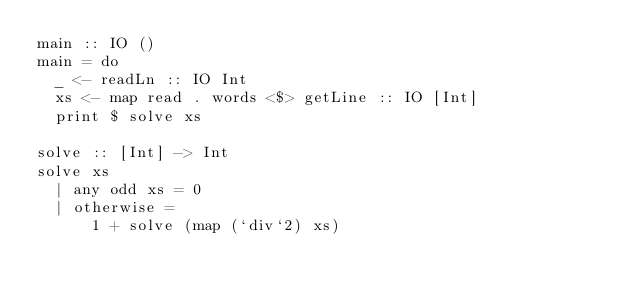Convert code to text. <code><loc_0><loc_0><loc_500><loc_500><_Haskell_>main :: IO ()
main = do
  _ <- readLn :: IO Int
  xs <- map read . words <$> getLine :: IO [Int]
  print $ solve xs

solve :: [Int] -> Int
solve xs 
  | any odd xs = 0
  | otherwise =
      1 + solve (map (`div`2) xs)</code> 